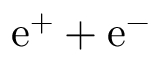Convert formula to latex. <formula><loc_0><loc_0><loc_500><loc_500>e ^ { + } + e ^ { - }</formula> 